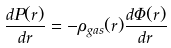Convert formula to latex. <formula><loc_0><loc_0><loc_500><loc_500>\frac { d P ( r ) } { d r } = - \rho _ { g a s } ( r ) \frac { d \Phi ( r ) } { d r }</formula> 